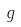Convert formula to latex. <formula><loc_0><loc_0><loc_500><loc_500>g</formula> 